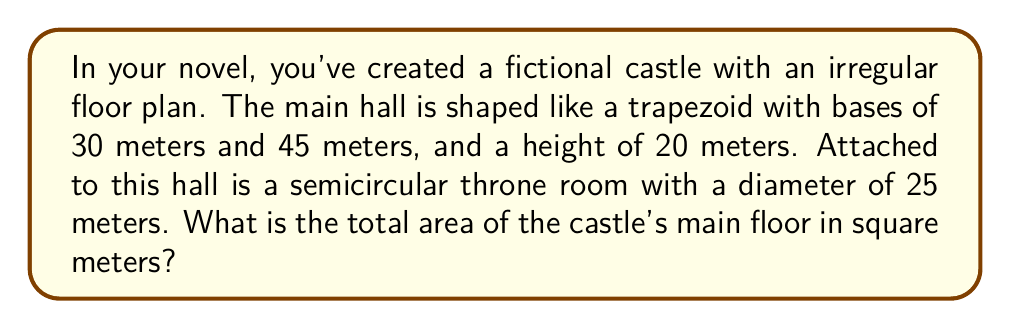Provide a solution to this math problem. To solve this problem, we need to calculate the areas of the trapezoid-shaped main hall and the semicircular throne room separately, then add them together.

1. Area of the trapezoid (main hall):
   The formula for the area of a trapezoid is:
   $$A_{trapezoid} = \frac{1}{2}(b_1 + b_2)h$$
   where $b_1$ and $b_2$ are the parallel sides and $h$ is the height.

   Plugging in our values:
   $$A_{trapezoid} = \frac{1}{2}(30 + 45) \times 20 = \frac{1}{2} \times 75 \times 20 = 750\text{ m}^2$$

2. Area of the semicircle (throne room):
   The formula for the area of a circle is $\pi r^2$, so for a semicircle, we use half of this:
   $$A_{semicircle} = \frac{1}{2} \pi r^2$$
   
   The radius is half the diameter, so $r = 25/2 = 12.5\text{ m}$
   
   $$A_{semicircle} = \frac{1}{2} \pi (12.5)^2 \approx 245.44\text{ m}^2$$

3. Total area:
   $$A_{total} = A_{trapezoid} + A_{semicircle} = 750 + 245.44 = 995.44\text{ m}^2$$

[asy]
unitsize(4mm);
path trapezoid = (0,0)--(9,0)--(6,5)--(3,5)--cycle;
path semicircle = arc((4.5,5), 2.5, 0, 180);
draw(trapezoid);
draw(semicircle);
label("30m", (1.5,0), S);
label("45m", (4.5,0), S);
label("20m", (0,2.5), W);
label("25m", (4.5,7.5), N);
[/asy]
Answer: 995.44 m² 